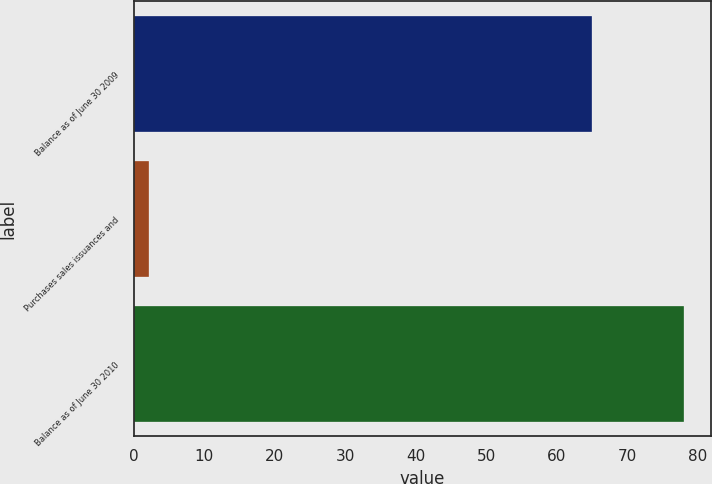Convert chart. <chart><loc_0><loc_0><loc_500><loc_500><bar_chart><fcel>Balance as of June 30 2009<fcel>Purchases sales issuances and<fcel>Balance as of June 30 2010<nl><fcel>65<fcel>2.1<fcel>78<nl></chart> 